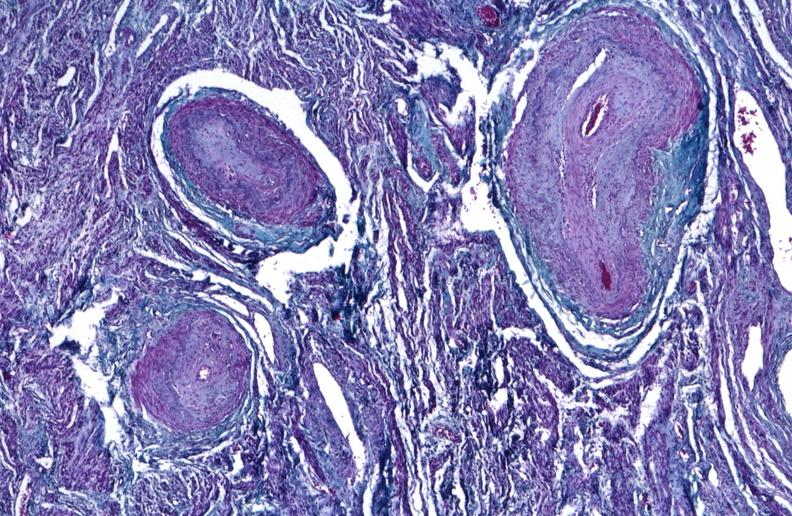do uterus stain?
Answer the question using a single word or phrase. No 